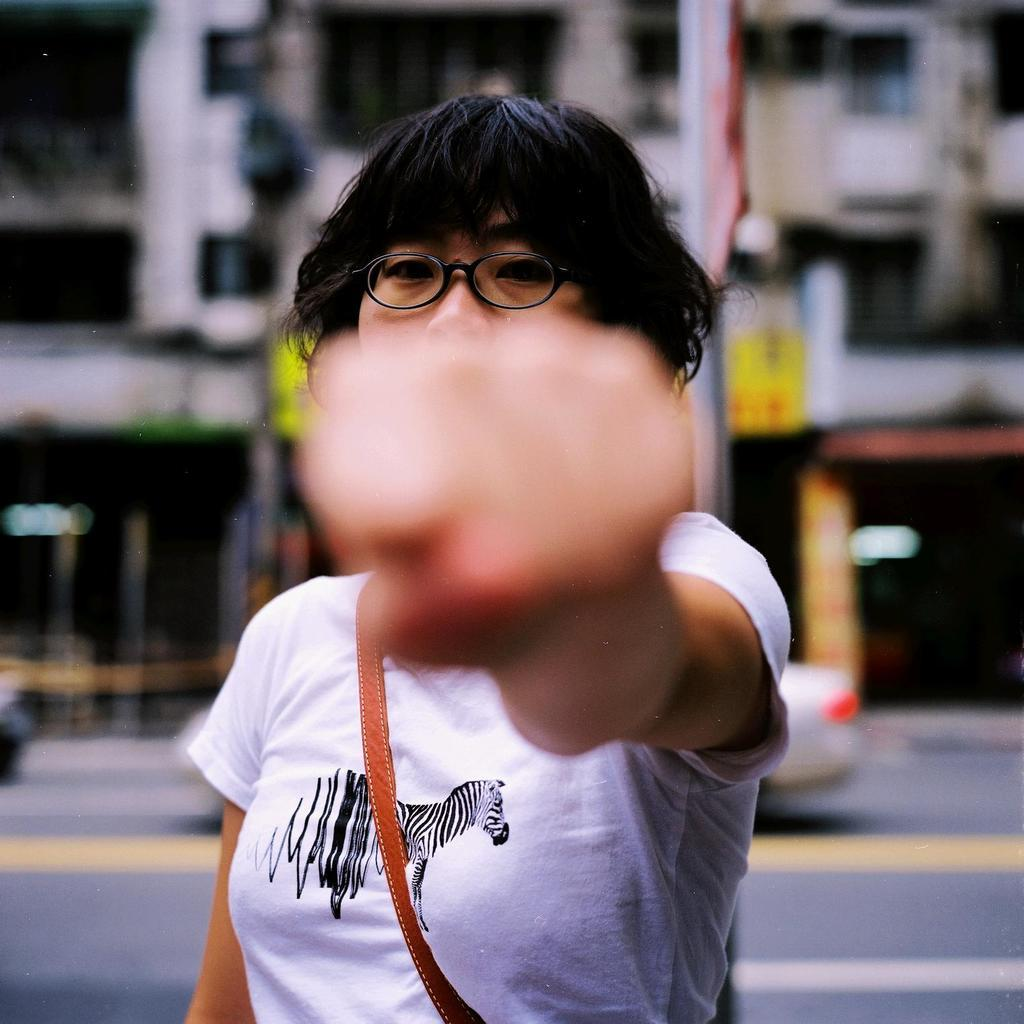What is the main subject of the image? There is a woman in the image. What is the woman doing in the image? The woman is standing in the image. What accessory is the woman wearing? The woman is wearing spectacles in the image. What type of structure can be seen in the background? There is a building in the image. What mode of transportation can be seen in the image? Cars are moving on the road in the image. What object is present in the image that is not related to the woman or the building? There is a pole in the image. What type of calculator is the woman using in the image? There is no calculator present in the image. What amusement park can be seen in the background of the image? There is no amusement park visible in the image; it features a building and a pole. 